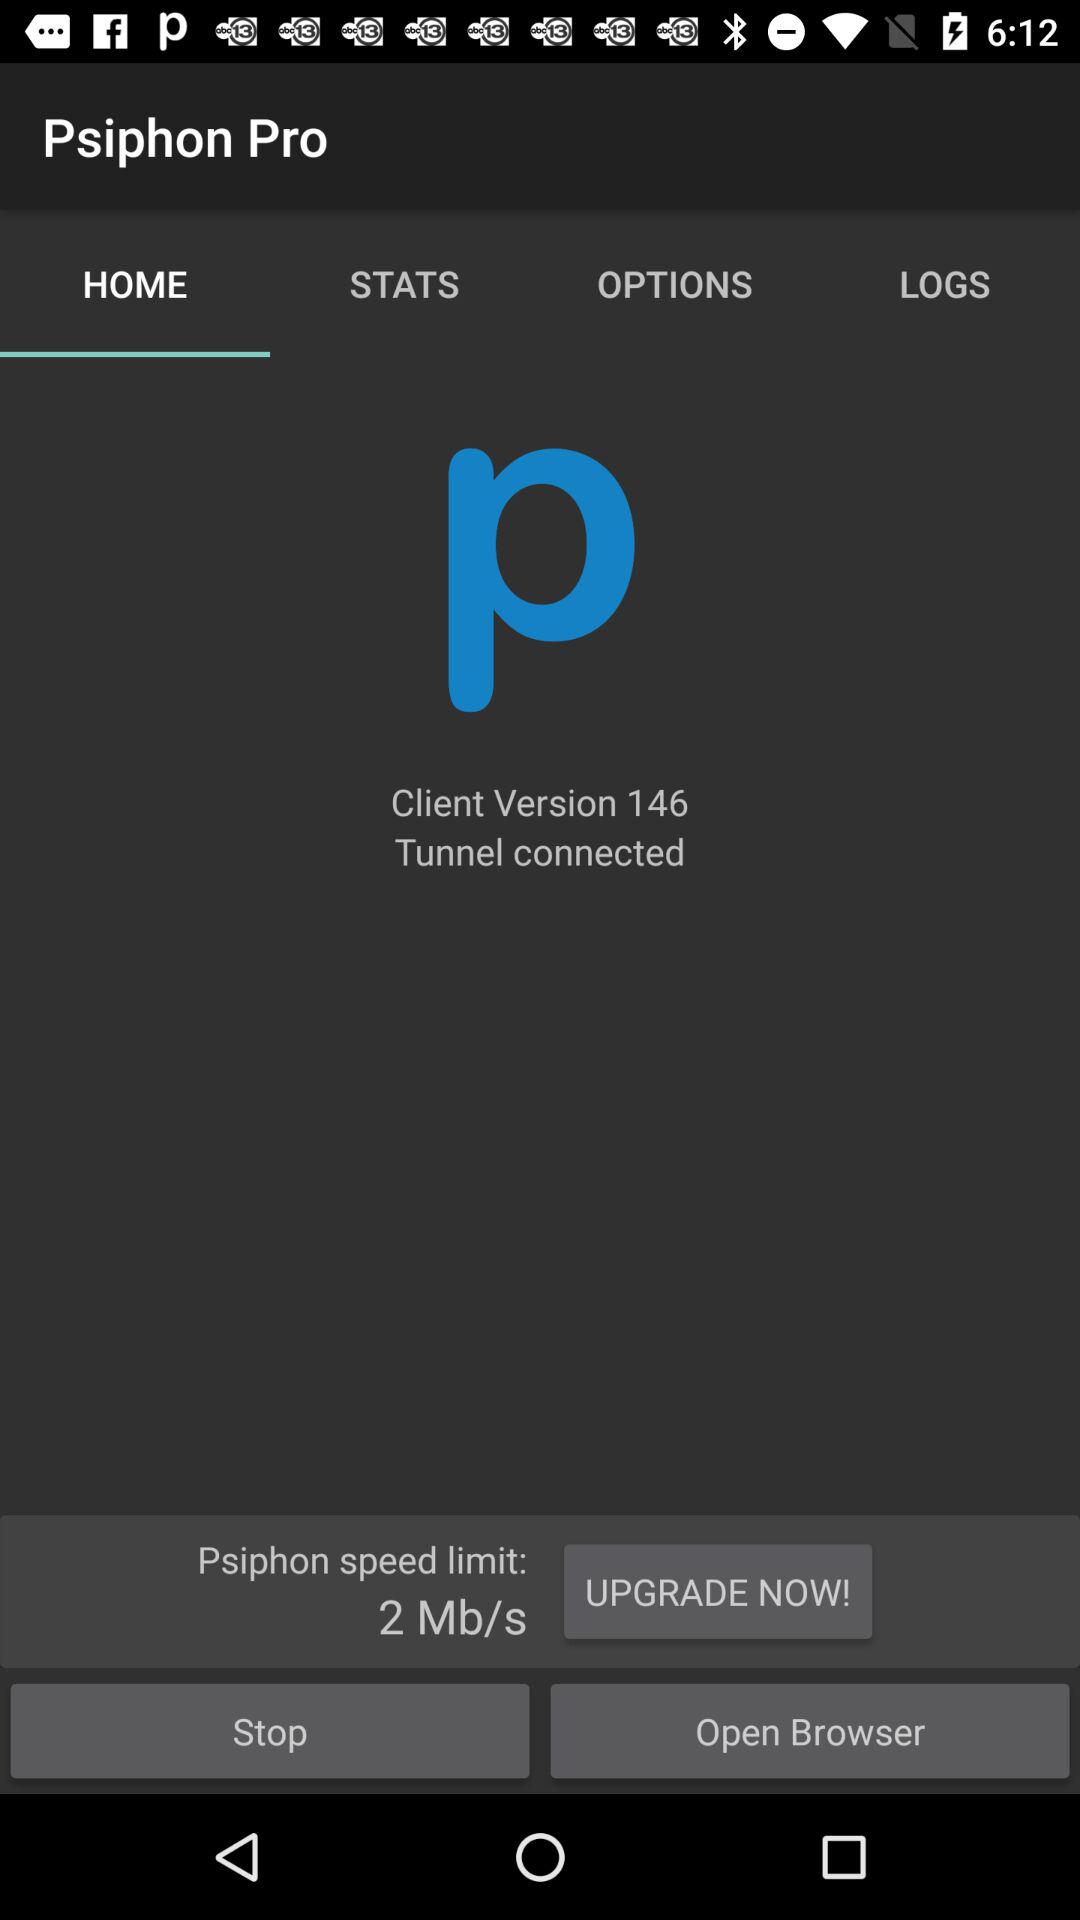What is the status of the tunnel? The status is "connected". 